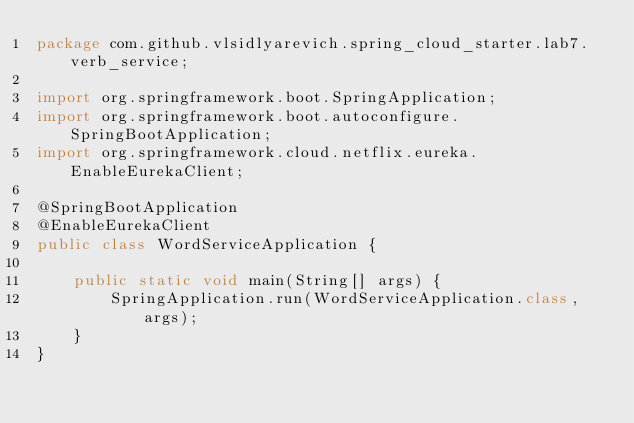<code> <loc_0><loc_0><loc_500><loc_500><_Java_>package com.github.vlsidlyarevich.spring_cloud_starter.lab7.verb_service;

import org.springframework.boot.SpringApplication;
import org.springframework.boot.autoconfigure.SpringBootApplication;
import org.springframework.cloud.netflix.eureka.EnableEurekaClient;

@SpringBootApplication
@EnableEurekaClient
public class WordServiceApplication {

    public static void main(String[] args) {
        SpringApplication.run(WordServiceApplication.class, args);
    }
}
</code> 